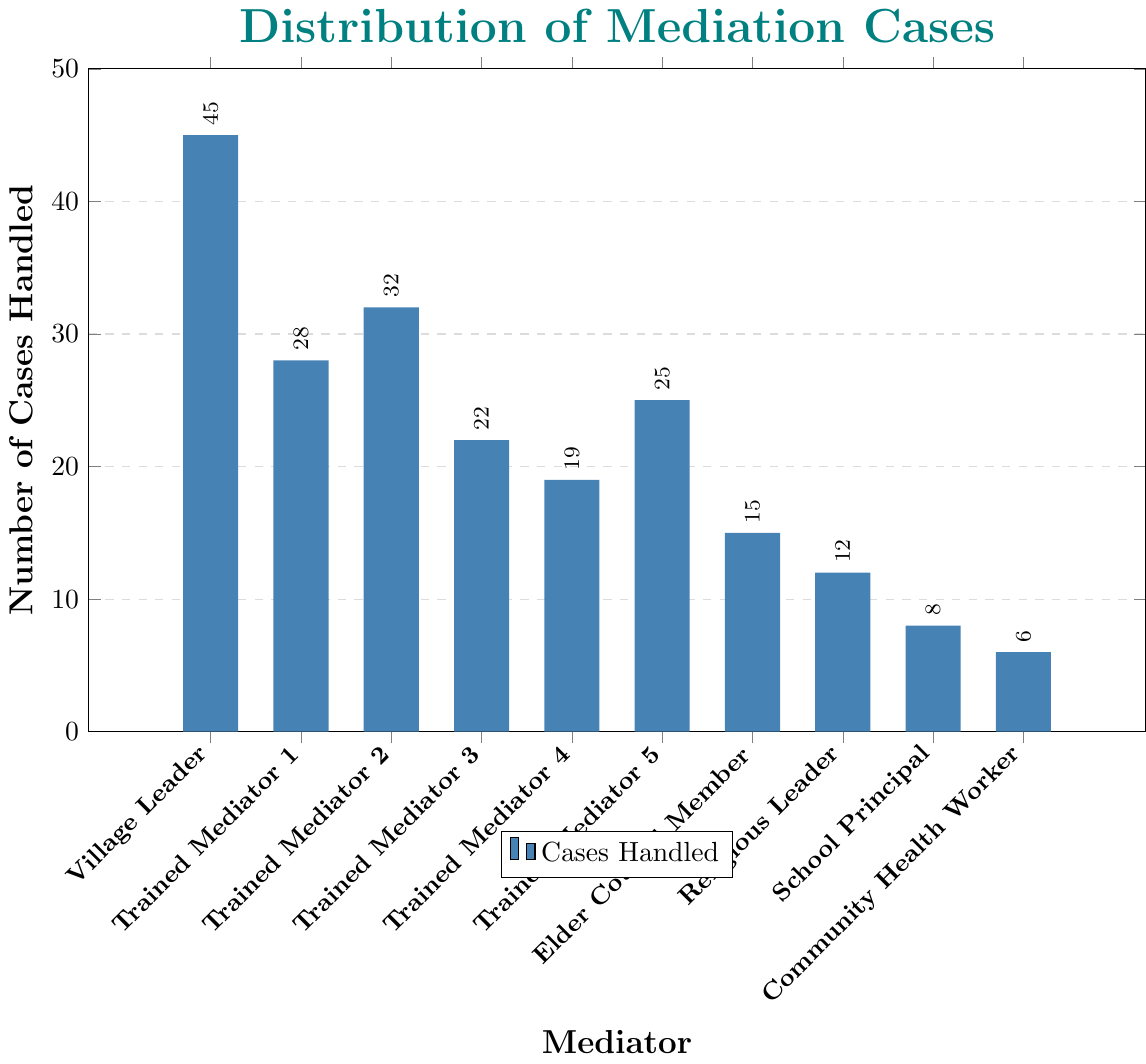Which mediator handled the fewest cases? By checking the heights of all the bars, the Community Health Worker has the shortest bar, indicating they handled the fewest cases.
Answer: Community Health Worker How many more cases did the Village Leader handle than Trained Mediator 3? The Village Leader handled 45 cases, and Trained Mediator 3 handled 22. Subtracting these, \(45 - 22 = 23\).
Answer: 23 What is the total number of cases handled by all trained mediators combined (excluding the Village Leader)? Adding the cases handled by Trained Mediator 1 (28), Trained Mediator 2 (32), Trained Mediator 3 (22), Trained Mediator 4 (19), and Trained Mediator 5 (25): \(28 + 32 + 22 + 19 + 25 = 126\).
Answer: 126 Which mediator handled more cases: Elder Council Member or Religious Leader? Checking the heights of their bars, the Elder Council Member handled 15 cases, which is higher than the Religious Leader's 12 cases.
Answer: Elder Council Member What is the average number of cases handled by the Village Leader and Trained Mediator 2? Adding the cases handled by the Village Leader (45) and Trained Mediator 2 (32) and then dividing by 2, \((45 + 32) / 2 = 77 / 2 = 38.5\).
Answer: 38.5 What is the combined total of cases handled by the School Principal and the Community Health Worker? Adding the cases handled by the School Principal (8) and the Community Health Worker (6), \(8 + 6 = 14\).
Answer: 14 Which two mediators handled the same number of cases? By reviewing the bars, there are no two mediators with the exact same number of cases displayed.
Answer: None How many fewer cases did the School Principal handle than the Village Leader? The Village Leader handled 45 cases and the School Principal handled 8, so \(45 - 8 = 37\).
Answer: 37 Which mediator has the second-most cases handled? After the Village Leader (45 cases), Trained Mediator 2 has the next tallest bar with 32 cases.
Answer: Trained Mediator 2 